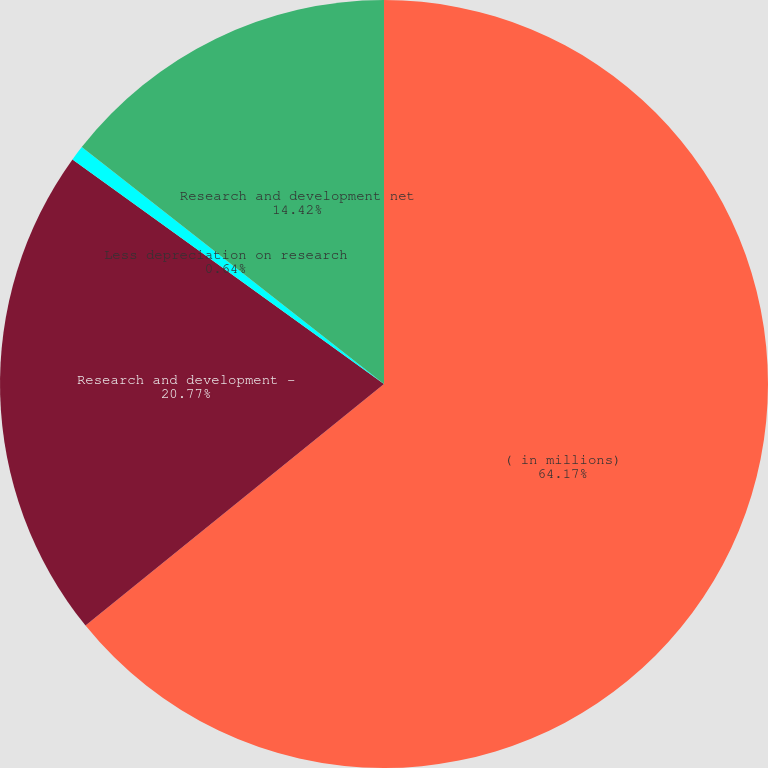Convert chart to OTSL. <chart><loc_0><loc_0><loc_500><loc_500><pie_chart><fcel>( in millions)<fcel>Research and development -<fcel>Less depreciation on research<fcel>Research and development net<nl><fcel>64.17%<fcel>20.77%<fcel>0.64%<fcel>14.42%<nl></chart> 